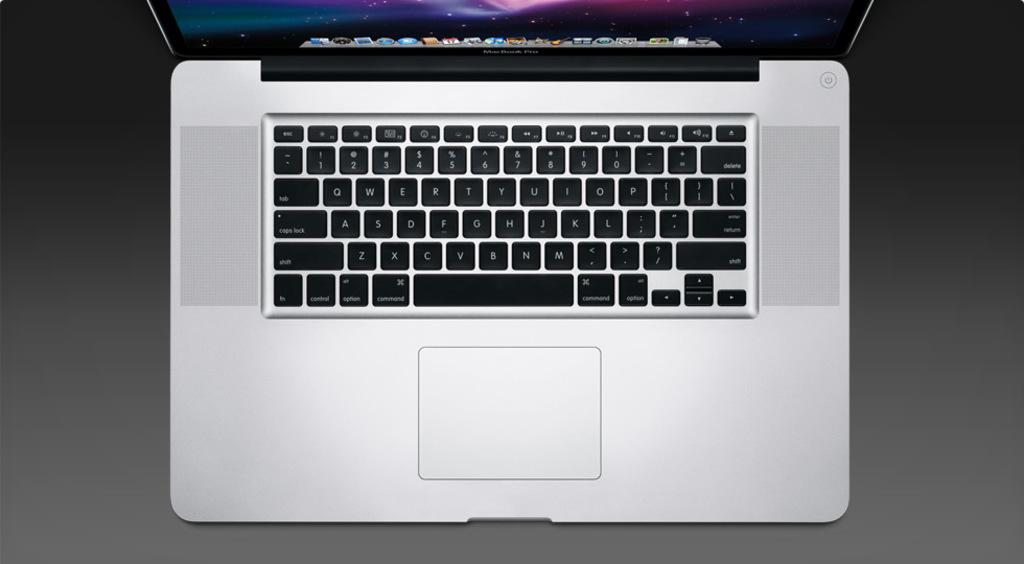<image>
Create a compact narrative representing the image presented. the letter M is on the keyboard with a silver background 